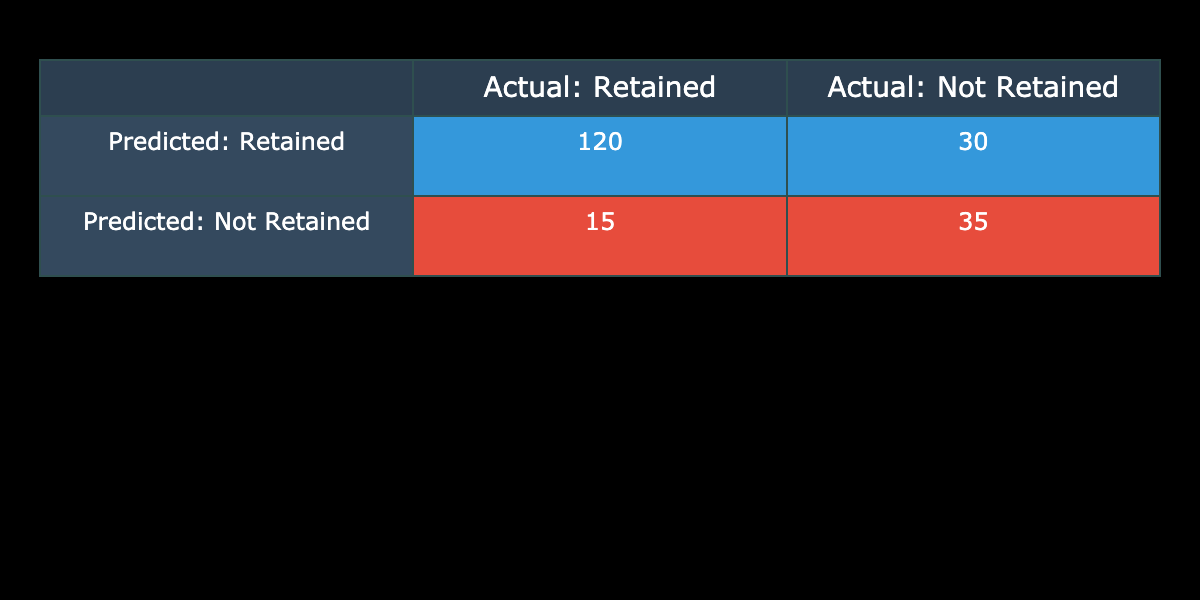What is the total number of students predicted to be retained? The table indicates 120 students predicted to be retained under the "Predicted: Retained" category, and 15 students predicted to be retained under the "Predicted: Not Retained" category. Summing these values gives 120 + 15 = 135.
Answer: 135 How many students were actually not retained? The table shows that 30 students were predicted to be not retained under the "Predicted: Retained" category, and 35 students under the "Predicted: Not Retained" category. Adding these, we have 30 + 35 = 65 students actually not retained.
Answer: 65 What is the number of true positives in the predictions? The number of true positives corresponds to the students who were correctly predicted to be retained. From the table, that value is 120 under the "Predicted: Retained" category.
Answer: 120 Is it true that more students were retained than not retained based on the predictions? According to the table, 120 students were predicted to be retained, while 30 were predicted not retained. Since 120 is greater than 30, the statement is true.
Answer: Yes What is the total number of students whose retention was predicted incorrectly? The predicted incorrect retention happens in two scenarios: when a student that should have been retained was marked as not retained and when a student that should not have been retained was marked as retained. Here, 30 students were marked incorrectly in the "Predicted: Retained" and 15 students in the "Predicted: Not Retained." Adding these gives 30 + 15 = 45 students predicted incorrectly.
Answer: 45 How many students were correctly identified as not retained? The table indicates 35 students were correctly predicted as not retained in the "Predicted: Not Retained" category. This is the number we need.
Answer: 35 What is the difference between the number of predicted retained and predicted not retained students? In the table, the number of predicted retained students is 120 and the predicted not retained is 30. The difference is calculated as 120 - 30 = 90. Thus, there are more predicted retained students than predicted not retained by 90.
Answer: 90 How many students had a negative retention outcome who were predicted as retained? According to the table, 30 students were predicted to be retained but were actually not retained, indicating a negative retention outcome for those predictions.
Answer: 30 What proportion of total predictions correctly identify students as retained? The total predictions can be calculated by adding all the categories: 120 (Predicted: Retained) + 30 (Predicted: Not Retained) + 15 (Predicted: Retained) + 35 (Predicted: Not Retained) = 200. The number of correct predictions (true positives) is 120. Therefore, the proportion is 120 / 200 = 0.6 or 60%.
Answer: 60% 